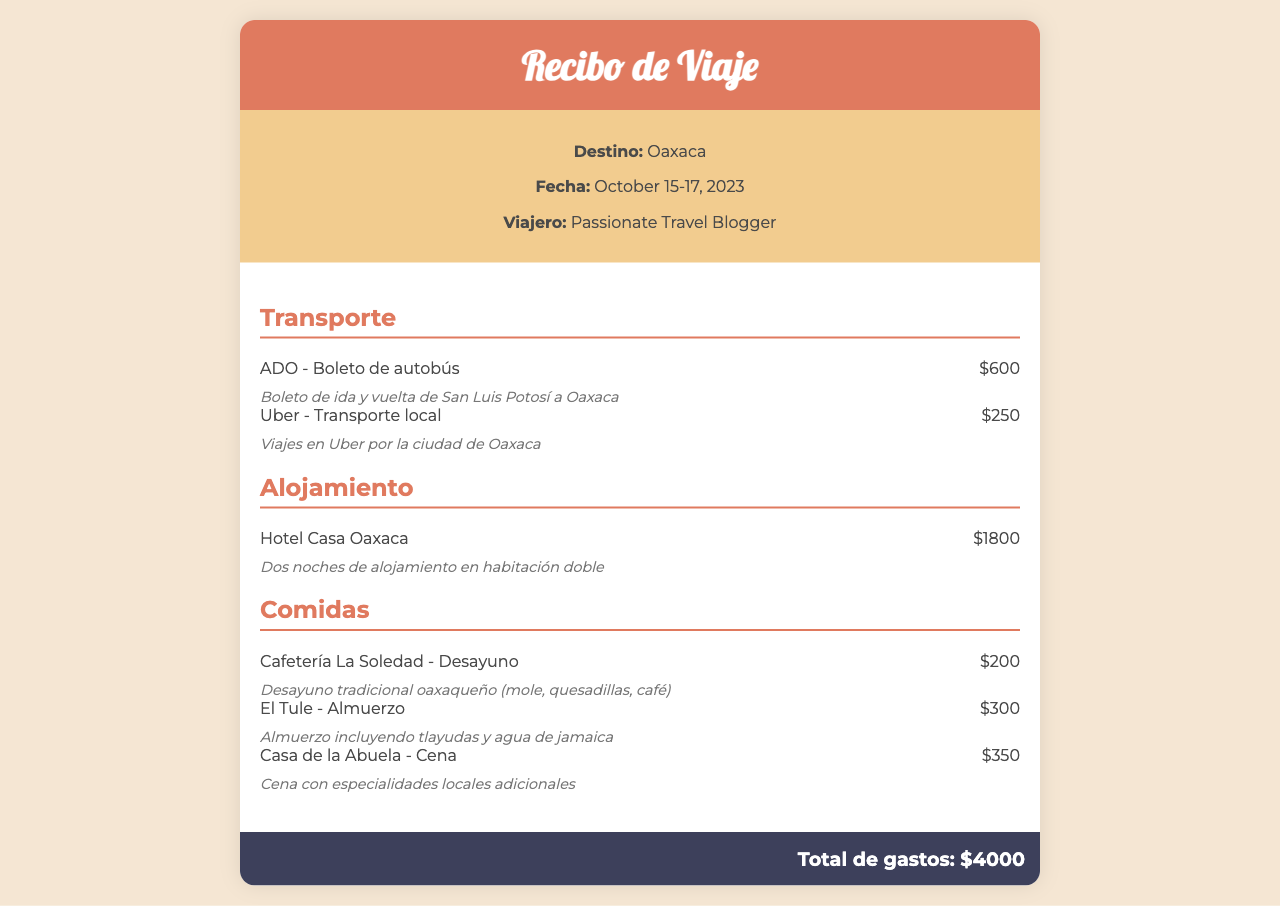what is the total amount of expenses? The total expenses are stated at the end of the document, which is $4000.
Answer: $4000 who is the traveler? The document lists the traveling individual as "Passionate Travel Blogger".
Answer: Passionate Travel Blogger what is the date of the trip? The receipt mentions the trip dates as October 15-17, 2023.
Answer: October 15-17, 2023 how much was spent on transportation? The total transportation expenses are the sum of ADO and Uber costs, which amounts to $600 + $250 = $850.
Answer: $850 where did the traveler stay? The accommodation listed in the document is "Hotel Casa Oaxaca".
Answer: Hotel Casa Oaxaca how much did the traveler spend on meals? The total meal expenses are calculated as $200 + $300 + $350, which equals $850.
Answer: $850 what type of transport was used for local trips? The document indicates that Uber was used for local transportation.
Answer: Uber how many nights did the traveler stay? The stay at Hotel Casa Oaxaca was for two nights, as mentioned in the accommodation description.
Answer: Two nights what kind of breakfast did the traveler have? The breakfast at Cafetería La Soledad included traditional Oaxacan food like mole and quesadillas.
Answer: Traditional oaxaqueño 